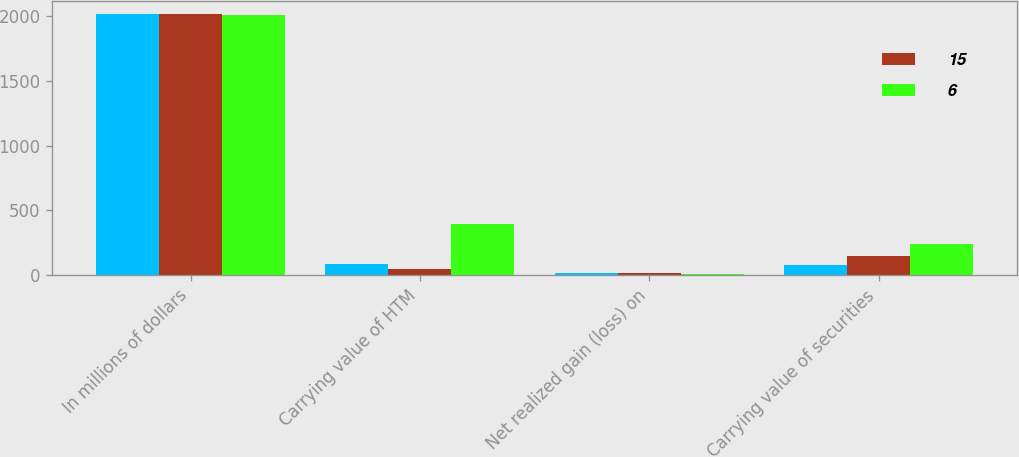Convert chart to OTSL. <chart><loc_0><loc_0><loc_500><loc_500><stacked_bar_chart><ecel><fcel>In millions of dollars<fcel>Carrying value of HTM<fcel>Net realized gain (loss) on<fcel>Carrying value of securities<nl><fcel>nan<fcel>2017<fcel>81<fcel>13<fcel>74<nl><fcel>15<fcel>2016<fcel>49<fcel>14<fcel>150<nl><fcel>6<fcel>2015<fcel>392<fcel>10<fcel>243<nl></chart> 